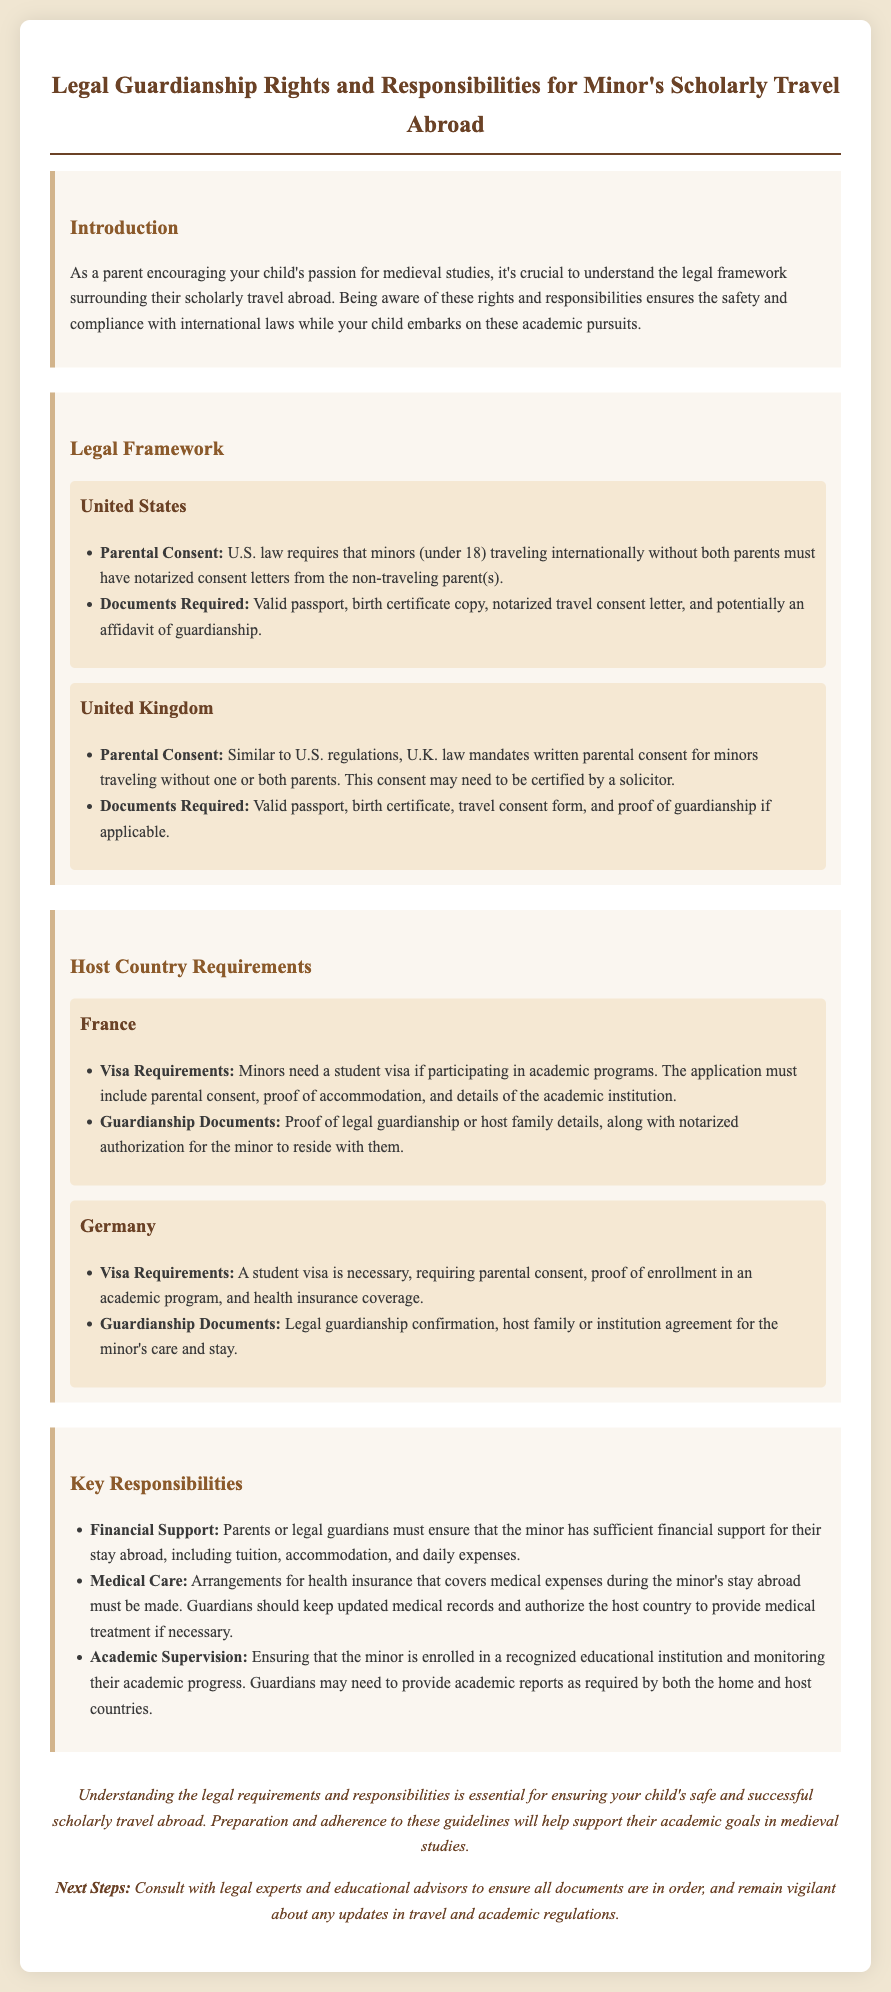What is required from non-traveling parents in the U.S.? U.S. law requires notarized consent letters from the non-traveling parent(s) for minors traveling internationally.
Answer: Notarized consent letters What document is needed for a minor to travel to France? For minors participating in academic programs in France, a student visa is required, including parental consent and proof of accommodation.
Answer: Student visa Which country requires consent to be certified by a solicitor? U.K. law mandates written parental consent for minors traveling without one or both parents, which may need to be certified by a solicitor.
Answer: United Kingdom What must parents ensure regarding a minor's finances while abroad? Parents or legal guardians must ensure that the minor has sufficient financial support for their stay abroad.
Answer: Sufficient financial support What is a key responsibility related to medical care? Guardians must make arrangements for health insurance that covers medical expenses during the minor's stay abroad.
Answer: Health insurance arrangements What academic obligation do guardians have? Ensuring that the minor is enrolled in a recognized educational institution and monitoring their academic progress is a key responsibility.
Answer: Enrollment and monitoring What legal document may be needed when traveling with a minor to Germany? Legal guardianship confirmation is required when traveling with a minor to Germany.
Answer: Legal guardianship confirmation What must guardians keep updated related to their child? Guardians should keep updated medical records and authorize the host country to provide medical treatment if necessary.
Answer: Updated medical records 